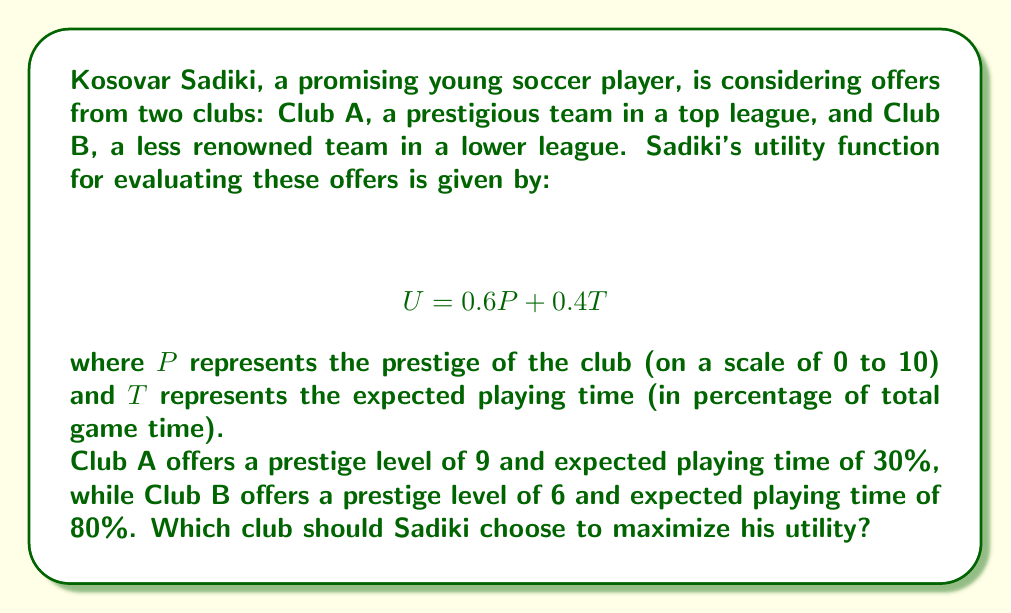Give your solution to this math problem. To solve this problem, we need to calculate the utility for each club using the given utility function and compare the results. Let's break it down step-by-step:

1. Utility function:
   $$ U = 0.6P + 0.4T $$

2. For Club A:
   - Prestige (P) = 9
   - Playing time (T) = 30%
   
   Calculating utility:
   $$ U_A = 0.6(9) + 0.4(30) $$
   $$ U_A = 5.4 + 12 $$
   $$ U_A = 17.4 $$

3. For Club B:
   - Prestige (P) = 6
   - Playing time (T) = 80%
   
   Calculating utility:
   $$ U_B = 0.6(6) + 0.4(80) $$
   $$ U_B = 3.6 + 32 $$
   $$ U_B = 35.6 $$

4. Comparing the utilities:
   Club A: $U_A = 17.4$
   Club B: $U_B = 35.6$

   Since $35.6 > 17.4$, Club B offers a higher utility.
Answer: Sadiki should choose Club B to maximize his utility, as it offers a higher utility value of 35.6 compared to Club A's utility value of 17.4. 